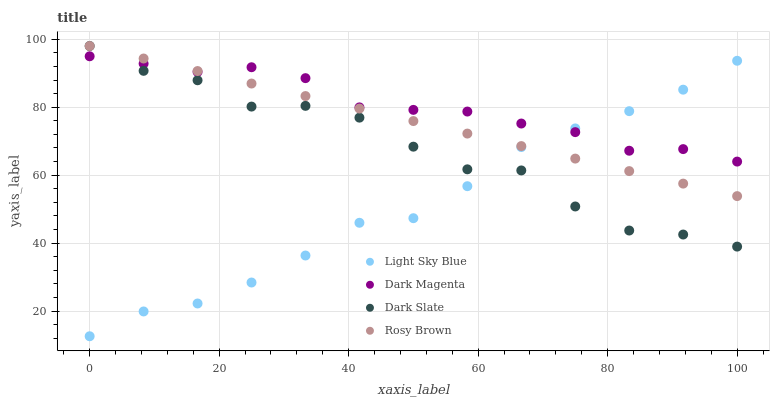Does Light Sky Blue have the minimum area under the curve?
Answer yes or no. Yes. Does Dark Magenta have the maximum area under the curve?
Answer yes or no. Yes. Does Rosy Brown have the minimum area under the curve?
Answer yes or no. No. Does Rosy Brown have the maximum area under the curve?
Answer yes or no. No. Is Rosy Brown the smoothest?
Answer yes or no. Yes. Is Dark Slate the roughest?
Answer yes or no. Yes. Is Light Sky Blue the smoothest?
Answer yes or no. No. Is Light Sky Blue the roughest?
Answer yes or no. No. Does Light Sky Blue have the lowest value?
Answer yes or no. Yes. Does Rosy Brown have the lowest value?
Answer yes or no. No. Does Rosy Brown have the highest value?
Answer yes or no. Yes. Does Light Sky Blue have the highest value?
Answer yes or no. No. Does Dark Slate intersect Light Sky Blue?
Answer yes or no. Yes. Is Dark Slate less than Light Sky Blue?
Answer yes or no. No. Is Dark Slate greater than Light Sky Blue?
Answer yes or no. No. 